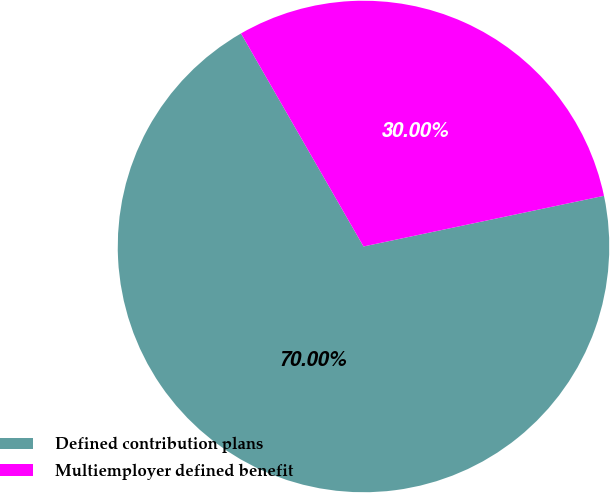<chart> <loc_0><loc_0><loc_500><loc_500><pie_chart><fcel>Defined contribution plans<fcel>Multiemployer defined benefit<nl><fcel>70.0%<fcel>30.0%<nl></chart> 